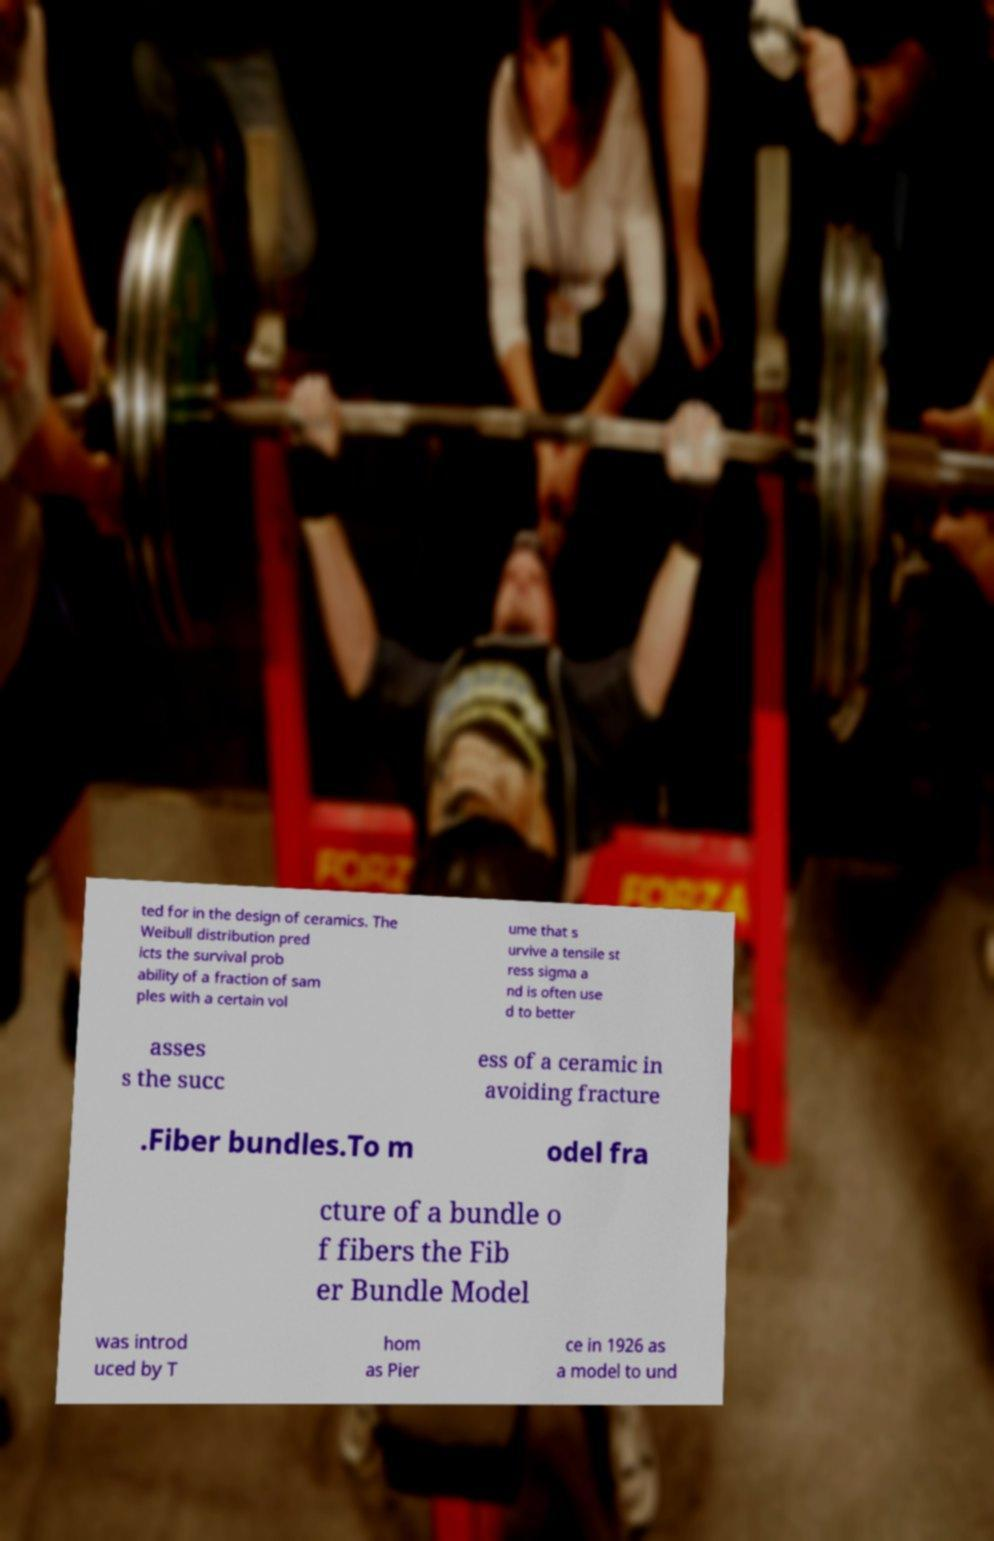Could you extract and type out the text from this image? ted for in the design of ceramics. The Weibull distribution pred icts the survival prob ability of a fraction of sam ples with a certain vol ume that s urvive a tensile st ress sigma a nd is often use d to better asses s the succ ess of a ceramic in avoiding fracture .Fiber bundles.To m odel fra cture of a bundle o f fibers the Fib er Bundle Model was introd uced by T hom as Pier ce in 1926 as a model to und 